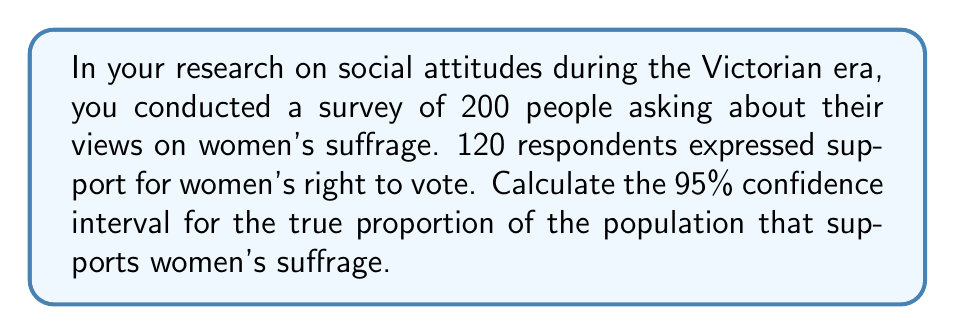Give your solution to this math problem. To calculate the confidence interval, we'll use the formula for the confidence interval of a proportion:

$$p \pm z \sqrt{\frac{p(1-p)}{n}}$$

Where:
$p$ = sample proportion
$z$ = z-score for desired confidence level (1.96 for 95% confidence)
$n$ = sample size

Step 1: Calculate the sample proportion $p$
$p = \frac{120}{200} = 0.6$

Step 2: Determine the z-score for 95% confidence
$z = 1.96$

Step 3: Calculate the margin of error
$\text{Margin of Error} = 1.96 \sqrt{\frac{0.6(1-0.6)}{200}}$
$= 1.96 \sqrt{\frac{0.24}{200}} = 1.96 \sqrt{0.0012} = 1.96 \times 0.0346 = 0.0679$

Step 4: Calculate the lower and upper bounds of the confidence interval
Lower bound: $0.6 - 0.0679 = 0.5321$
Upper bound: $0.6 + 0.0679 = 0.6679$

Therefore, the 95% confidence interval is (0.5321, 0.6679) or (53.21%, 66.79%).
Answer: (0.5321, 0.6679) 